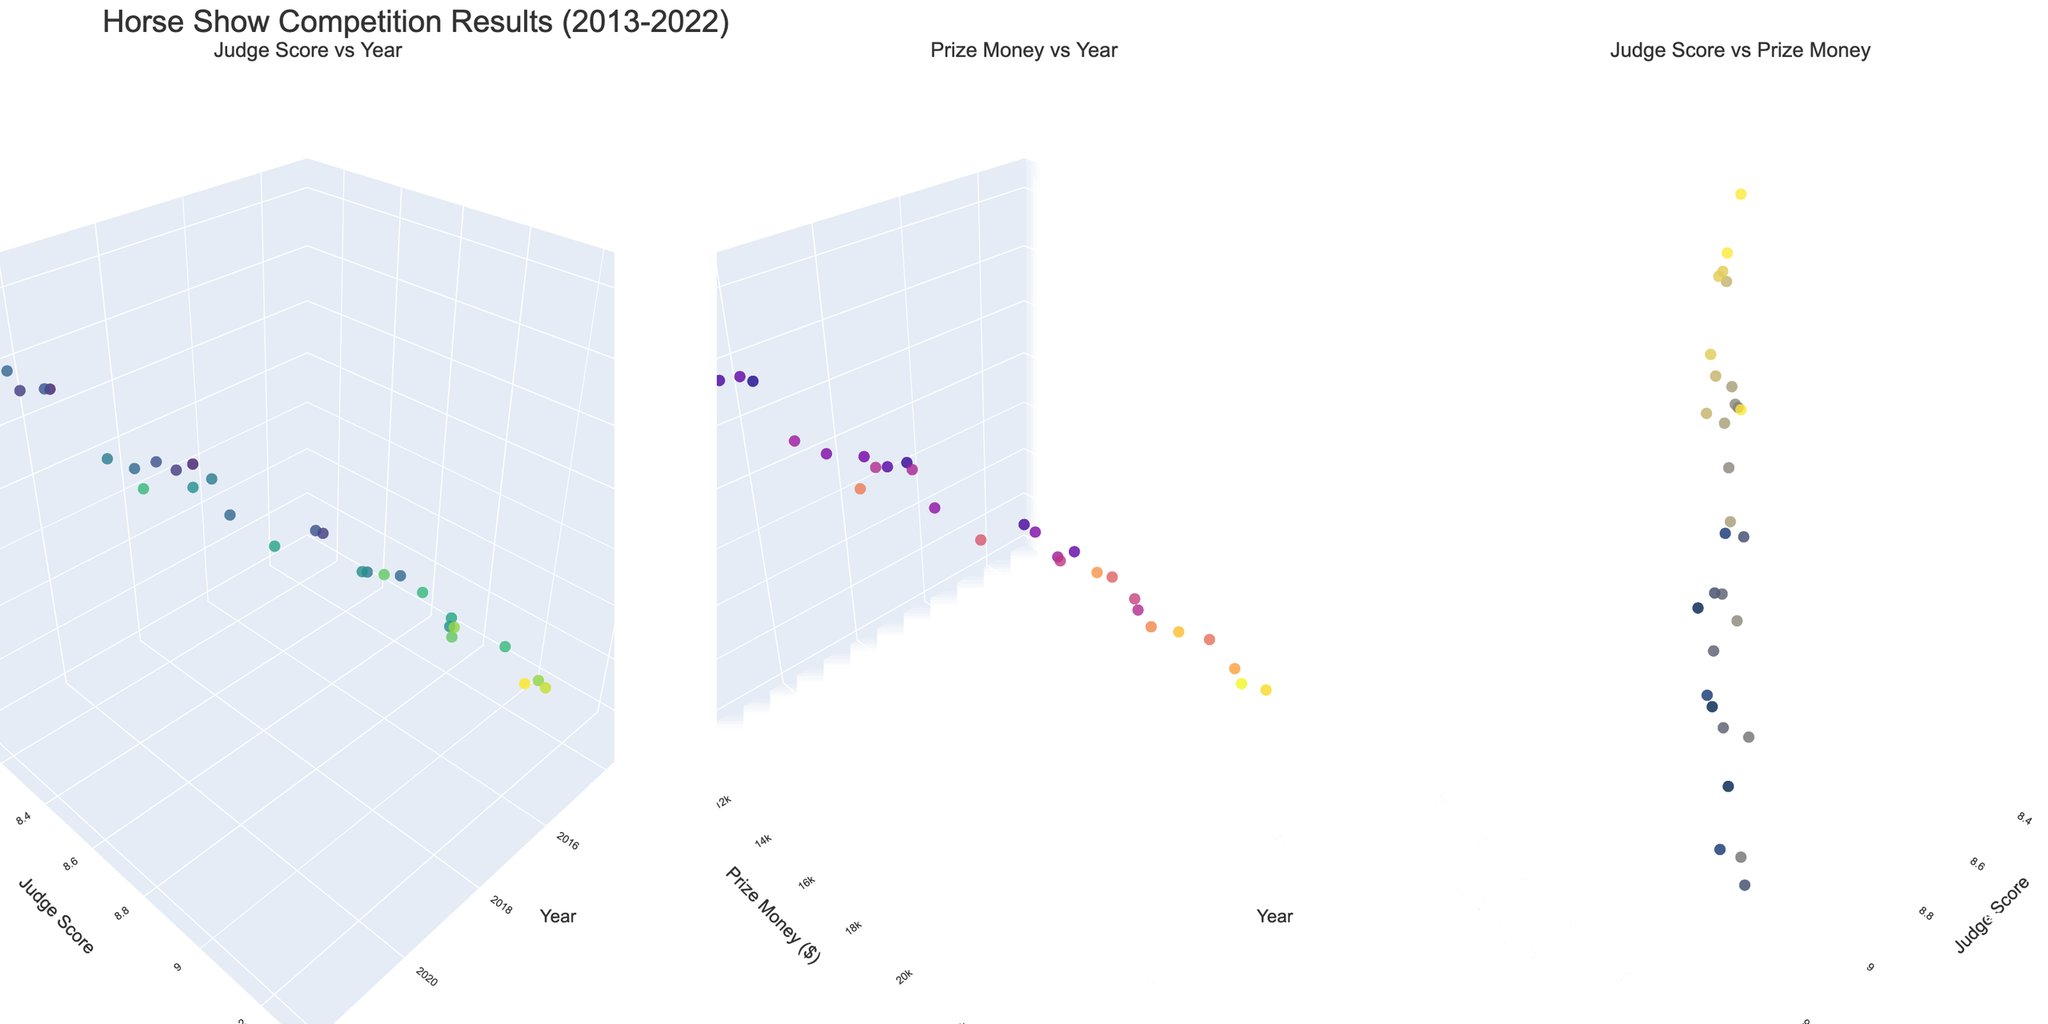what is the range of Judge Score from 2013 to 2022? First, look at "Judge Score vs Year" plot. Observe the minimum and maximum values of Judge Score on the y-axis from 2013 to 2022.
Answer: 8.1 - 9.3 Which breed had the highest Judge Score? In the "Judge Score vs Year" subplot, find the data point with the highest y-axis value (Judge Score). Read the respective breed on the z-axis.
Answer: Oldenburg What's the trend of prize money over the years? Refer to the "Prize Money vs Year" subplot. Observe how the values on the y-axis (Prize Money) change as you move along the x-axis (Year). Note any general increase, decrease, or fluctuation trends.
Answer: Increasing trend Which breed received the highest prize money in 2015? Look at the "Prize Money vs Year" subplot. Focus on the year 2015 on the x-axis. Identify the highest y-axis value (Prize Money) for this year and read the corresponding breed on the z-axis.
Answer: Dutch Warmblood Compare the average Judge Scores of the breeds that participated in 2016. Identify the data points on the "Judge Score vs Year" plot that corresponds to 2016. Sum their y-axis values (Judge Scores) and divide by the number of data points for 2016. Calculate the average.
Answer: (9.0 + 8.7 + 8.9) / 3 = 8.87 Which breed had the lowest prize money in 2018? In the "Prize Money vs Year" subplot, navigate to the year 2018 on the x-axis. Locate the lowest y-axis value (Prize Money) for this year and read the corresponding breed on the z-axis.
Answer: Clydesdale In which year did breed with highest Judge Score receive the highest prize money? Examine the "Judge Score vs Prize Money" subplot. Locate the data point with the highest x-axis value (Judge Score), then check its corresponding y-axis value (Prize Money). Trace the year of this breed in the "Judge Score vs Year" plot.
Answer: 2017 Which breed has the highest Judge Score in 2014, and which competition was it in? Look at the data points on the "Judge Score vs Year" plot for the year 2014 on the x-axis. Identify the one with the highest y-axis value (Judge Score) for that year and refer to the text description on hover to find the competition.
Answer: Hanoverian, Dressage at Devon 